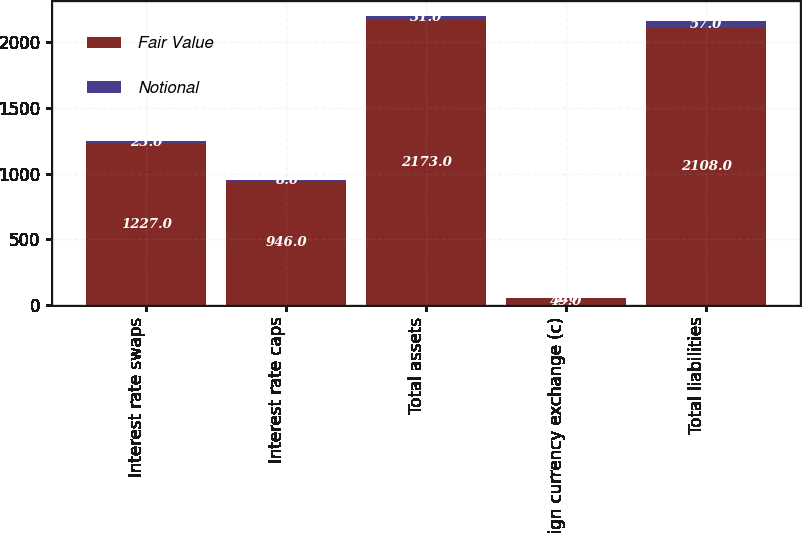Convert chart. <chart><loc_0><loc_0><loc_500><loc_500><stacked_bar_chart><ecel><fcel>Interest rate swaps<fcel>Interest rate caps<fcel>Total assets<fcel>Foreign currency exchange (c)<fcel>Total liabilities<nl><fcel>Fair Value<fcel>1227<fcel>946<fcel>2173<fcel>49<fcel>2108<nl><fcel>Notional<fcel>23<fcel>8<fcel>31<fcel>2<fcel>57<nl></chart> 